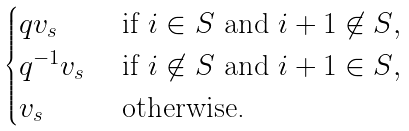Convert formula to latex. <formula><loc_0><loc_0><loc_500><loc_500>\begin{cases} q v _ { s } & \text { if $i\in S$ and $i+1\not\in S$} , \\ q ^ { - 1 } v _ { s } & \text { if $i\not\in S$ and $i+1\in S$} , \\ v _ { s } & \text { otherwise.} \end{cases}</formula> 